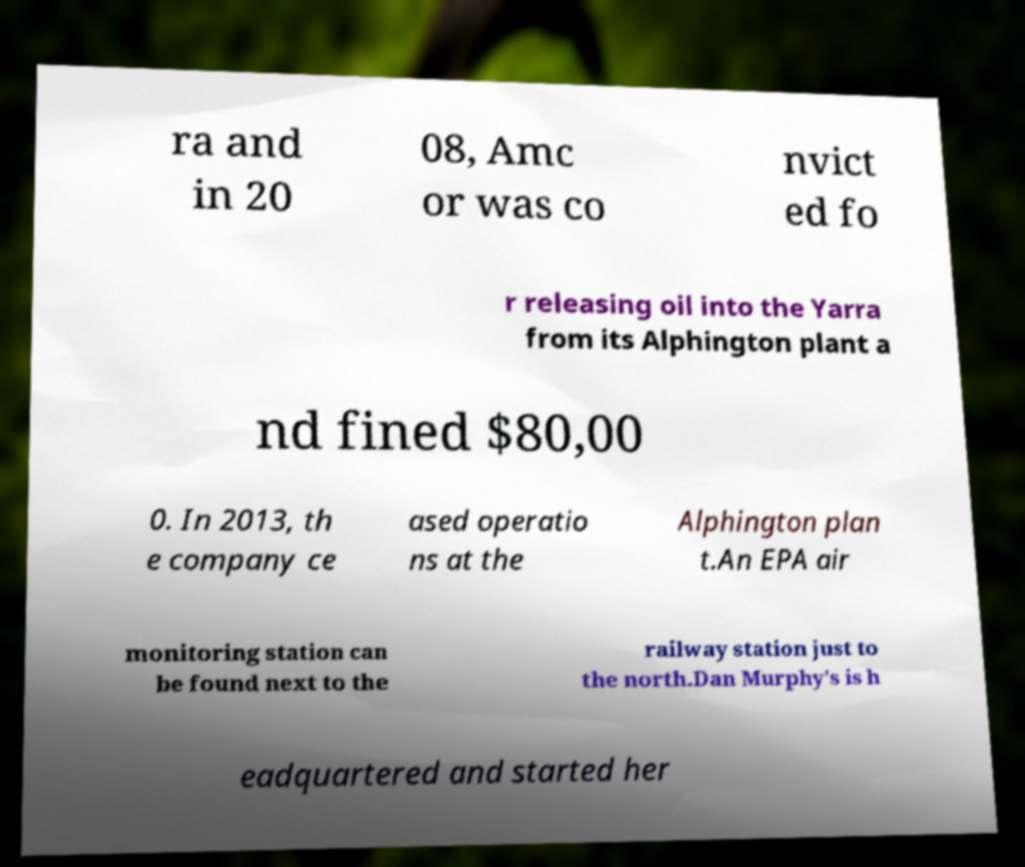For documentation purposes, I need the text within this image transcribed. Could you provide that? ra and in 20 08, Amc or was co nvict ed fo r releasing oil into the Yarra from its Alphington plant a nd fined $80,00 0. In 2013, th e company ce ased operatio ns at the Alphington plan t.An EPA air monitoring station can be found next to the railway station just to the north.Dan Murphy's is h eadquartered and started her 